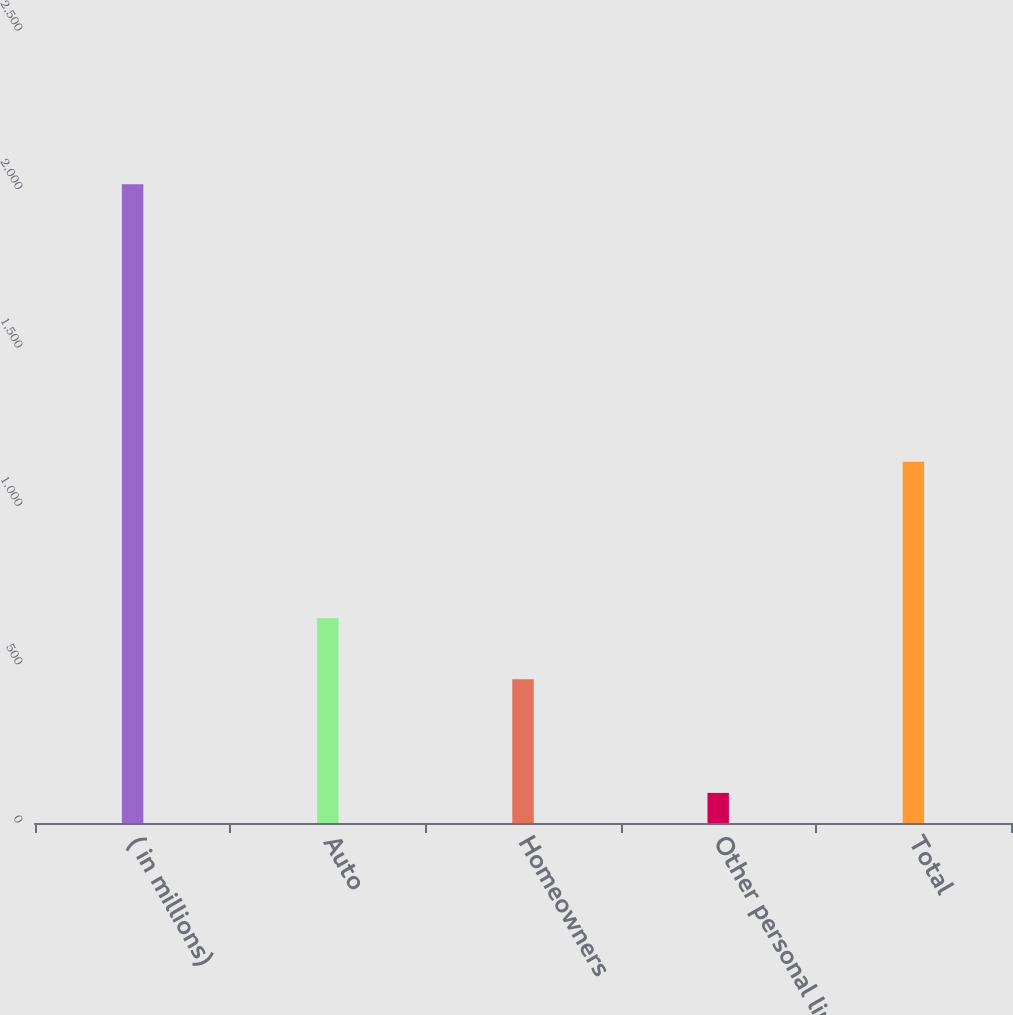<chart> <loc_0><loc_0><loc_500><loc_500><bar_chart><fcel>( in millions)<fcel>Auto<fcel>Homeowners<fcel>Other personal lines<fcel>Total<nl><fcel>2016<fcel>646.1<fcel>454<fcel>95<fcel>1140<nl></chart> 